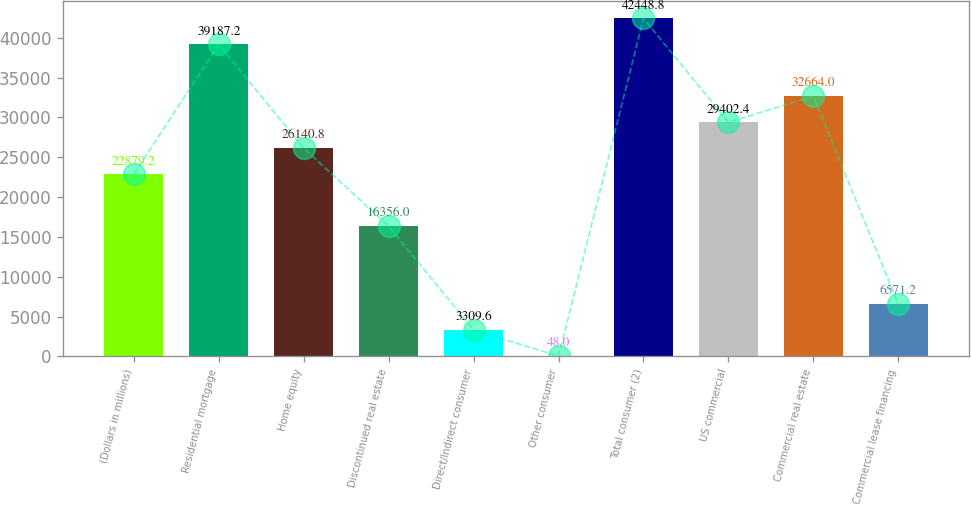Convert chart to OTSL. <chart><loc_0><loc_0><loc_500><loc_500><bar_chart><fcel>(Dollars in millions)<fcel>Residential mortgage<fcel>Home equity<fcel>Discontinued real estate<fcel>Direct/Indirect consumer<fcel>Other consumer<fcel>Total consumer (2)<fcel>US commercial<fcel>Commercial real estate<fcel>Commercial lease financing<nl><fcel>22879.2<fcel>39187.2<fcel>26140.8<fcel>16356<fcel>3309.6<fcel>48<fcel>42448.8<fcel>29402.4<fcel>32664<fcel>6571.2<nl></chart> 